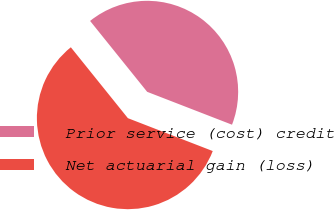Convert chart. <chart><loc_0><loc_0><loc_500><loc_500><pie_chart><fcel>Prior service (cost) credit<fcel>Net actuarial gain (loss)<nl><fcel>41.67%<fcel>58.33%<nl></chart> 